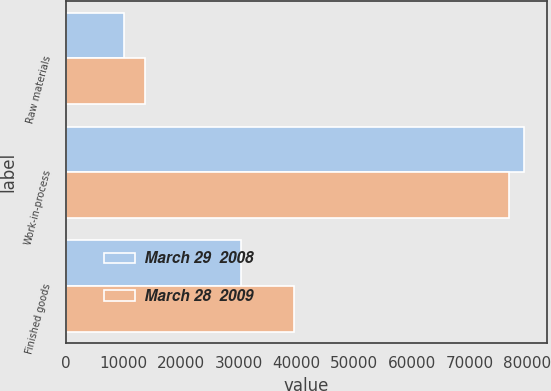<chart> <loc_0><loc_0><loc_500><loc_500><stacked_bar_chart><ecel><fcel>Raw materials<fcel>Work-in-process<fcel>Finished goods<nl><fcel>March 29  2008<fcel>10024<fcel>79426<fcel>30382<nl><fcel>March 28  2009<fcel>13771<fcel>76870<fcel>39609<nl></chart> 